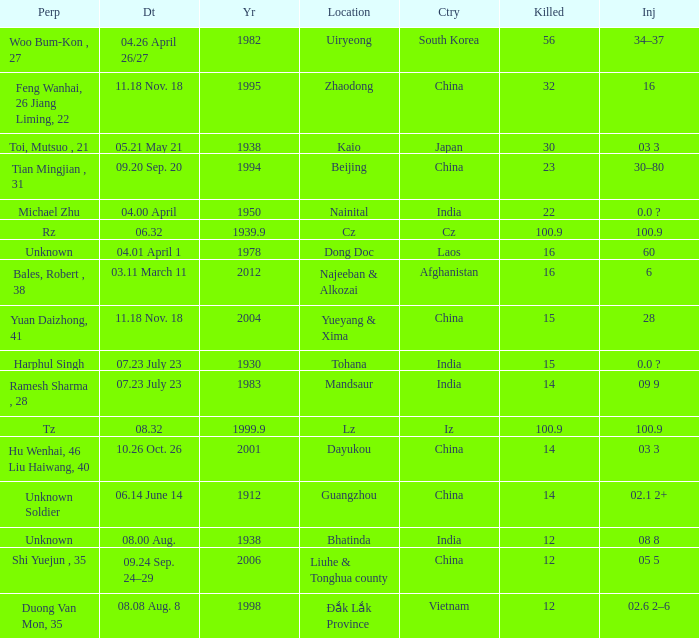What is the date, when the country is "china", and the perpetrator is "shi yuejun , 35"? 09.24 Sep. 24–29. 